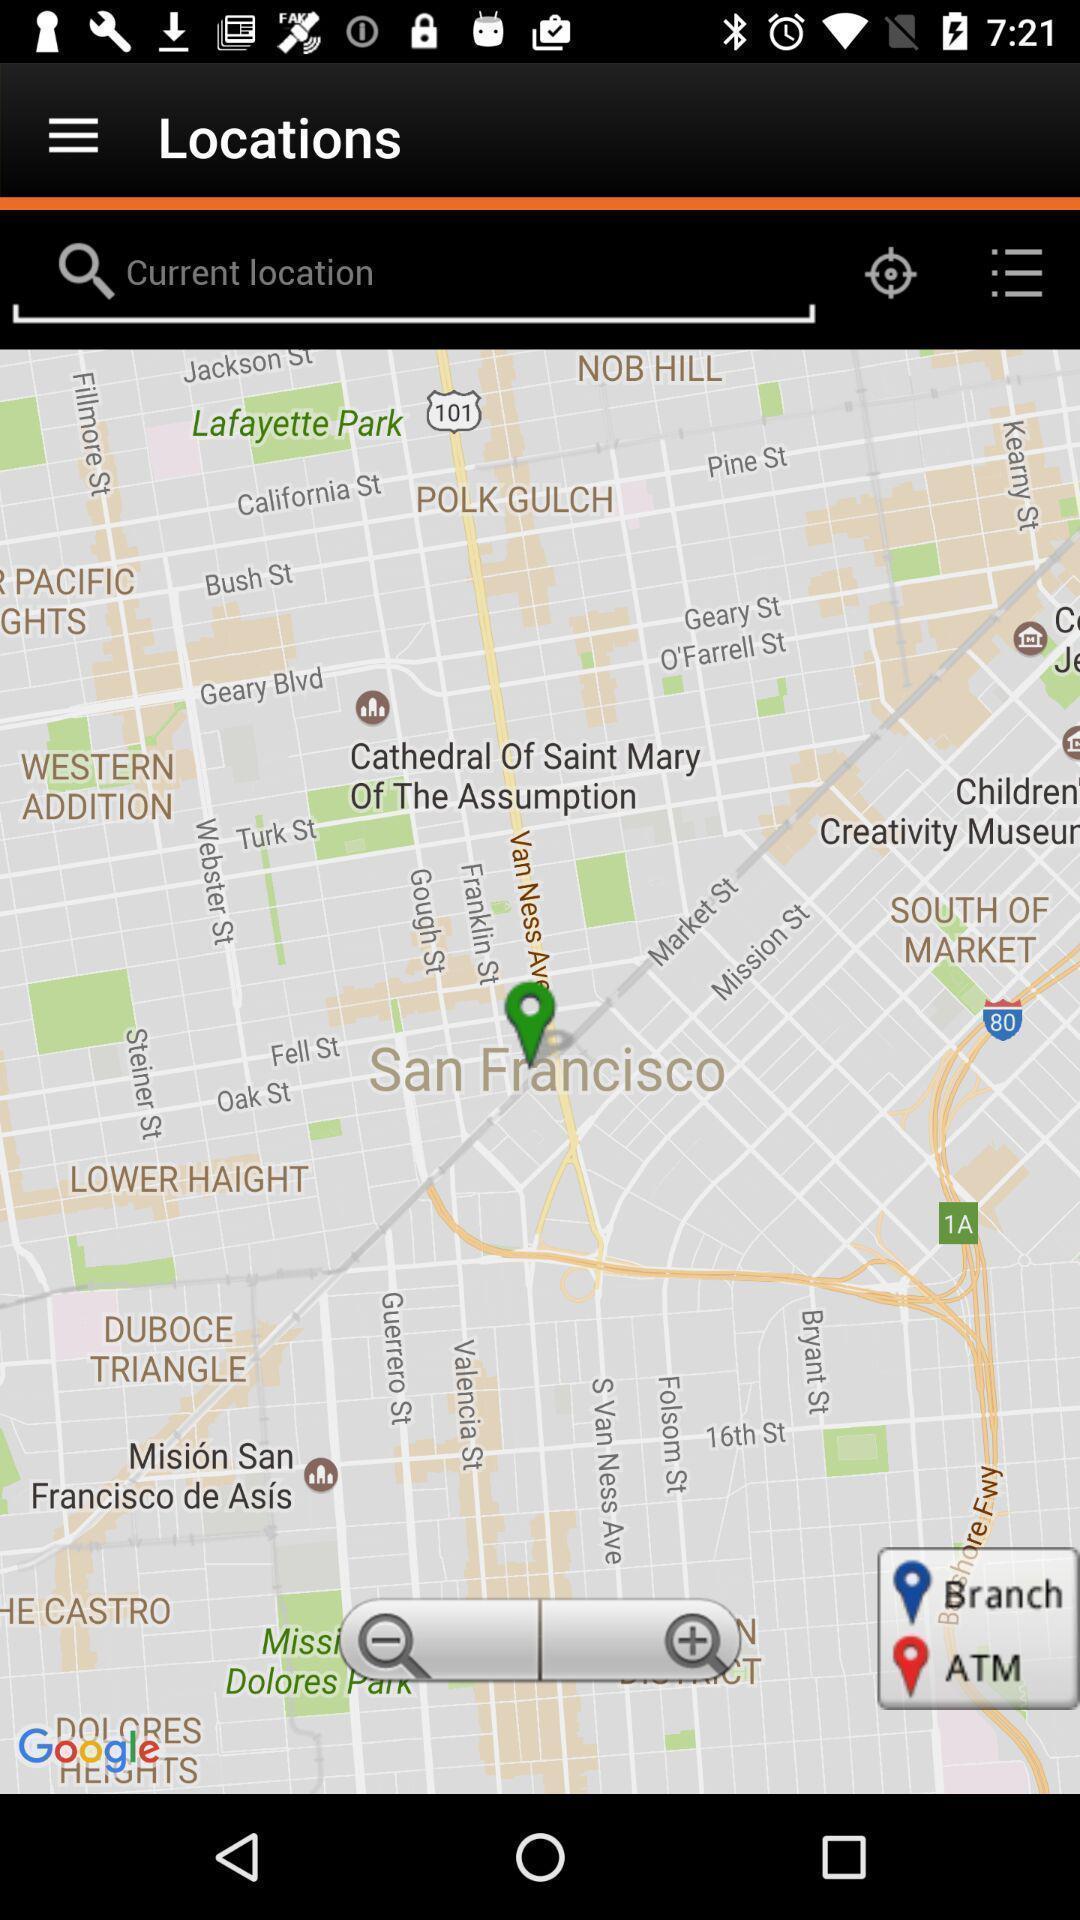Describe the content in this image. Search bar to search for the location. 